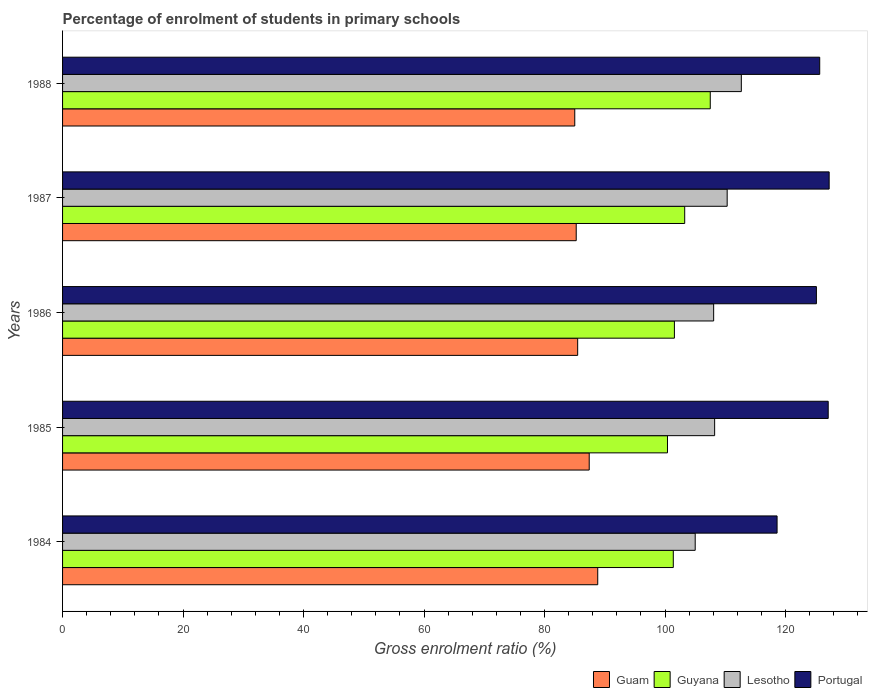How many groups of bars are there?
Provide a succinct answer. 5. Are the number of bars per tick equal to the number of legend labels?
Provide a short and direct response. Yes. What is the label of the 5th group of bars from the top?
Provide a short and direct response. 1984. In how many cases, is the number of bars for a given year not equal to the number of legend labels?
Provide a succinct answer. 0. What is the percentage of students enrolled in primary schools in Lesotho in 1985?
Ensure brevity in your answer.  108.23. Across all years, what is the maximum percentage of students enrolled in primary schools in Portugal?
Provide a succinct answer. 127.24. Across all years, what is the minimum percentage of students enrolled in primary schools in Guyana?
Provide a succinct answer. 100.4. In which year was the percentage of students enrolled in primary schools in Portugal minimum?
Your answer should be compact. 1984. What is the total percentage of students enrolled in primary schools in Guam in the graph?
Give a very brief answer. 432. What is the difference between the percentage of students enrolled in primary schools in Lesotho in 1984 and that in 1985?
Offer a very short reply. -3.23. What is the difference between the percentage of students enrolled in primary schools in Guam in 1987 and the percentage of students enrolled in primary schools in Lesotho in 1984?
Keep it short and to the point. -19.75. What is the average percentage of students enrolled in primary schools in Portugal per year?
Provide a short and direct response. 124.74. In the year 1986, what is the difference between the percentage of students enrolled in primary schools in Guam and percentage of students enrolled in primary schools in Lesotho?
Ensure brevity in your answer.  -22.57. What is the ratio of the percentage of students enrolled in primary schools in Lesotho in 1985 to that in 1987?
Your answer should be very brief. 0.98. What is the difference between the highest and the second highest percentage of students enrolled in primary schools in Guam?
Provide a succinct answer. 1.41. What is the difference between the highest and the lowest percentage of students enrolled in primary schools in Portugal?
Offer a terse response. 8.65. Is it the case that in every year, the sum of the percentage of students enrolled in primary schools in Guyana and percentage of students enrolled in primary schools in Portugal is greater than the sum of percentage of students enrolled in primary schools in Lesotho and percentage of students enrolled in primary schools in Guam?
Provide a short and direct response. No. What does the 1st bar from the top in 1985 represents?
Provide a succinct answer. Portugal. What does the 3rd bar from the bottom in 1985 represents?
Provide a short and direct response. Lesotho. Is it the case that in every year, the sum of the percentage of students enrolled in primary schools in Lesotho and percentage of students enrolled in primary schools in Portugal is greater than the percentage of students enrolled in primary schools in Guam?
Your answer should be very brief. Yes. Are all the bars in the graph horizontal?
Provide a succinct answer. Yes. Does the graph contain grids?
Give a very brief answer. No. How many legend labels are there?
Your response must be concise. 4. What is the title of the graph?
Give a very brief answer. Percentage of enrolment of students in primary schools. What is the label or title of the X-axis?
Offer a terse response. Gross enrolment ratio (%). What is the label or title of the Y-axis?
Provide a succinct answer. Years. What is the Gross enrolment ratio (%) in Guam in 1984?
Your response must be concise. 88.83. What is the Gross enrolment ratio (%) of Guyana in 1984?
Give a very brief answer. 101.37. What is the Gross enrolment ratio (%) in Lesotho in 1984?
Provide a short and direct response. 105. What is the Gross enrolment ratio (%) in Portugal in 1984?
Ensure brevity in your answer.  118.59. What is the Gross enrolment ratio (%) of Guam in 1985?
Your answer should be very brief. 87.41. What is the Gross enrolment ratio (%) of Guyana in 1985?
Give a very brief answer. 100.4. What is the Gross enrolment ratio (%) of Lesotho in 1985?
Your answer should be compact. 108.23. What is the Gross enrolment ratio (%) in Portugal in 1985?
Your answer should be compact. 127.08. What is the Gross enrolment ratio (%) of Guam in 1986?
Provide a succinct answer. 85.5. What is the Gross enrolment ratio (%) in Guyana in 1986?
Keep it short and to the point. 101.55. What is the Gross enrolment ratio (%) of Lesotho in 1986?
Offer a terse response. 108.07. What is the Gross enrolment ratio (%) in Portugal in 1986?
Make the answer very short. 125.12. What is the Gross enrolment ratio (%) in Guam in 1987?
Offer a very short reply. 85.26. What is the Gross enrolment ratio (%) of Guyana in 1987?
Offer a terse response. 103.26. What is the Gross enrolment ratio (%) of Lesotho in 1987?
Offer a very short reply. 110.31. What is the Gross enrolment ratio (%) of Portugal in 1987?
Keep it short and to the point. 127.24. What is the Gross enrolment ratio (%) in Guam in 1988?
Provide a succinct answer. 85.01. What is the Gross enrolment ratio (%) in Guyana in 1988?
Ensure brevity in your answer.  107.5. What is the Gross enrolment ratio (%) in Lesotho in 1988?
Give a very brief answer. 112.66. What is the Gross enrolment ratio (%) in Portugal in 1988?
Ensure brevity in your answer.  125.67. Across all years, what is the maximum Gross enrolment ratio (%) of Guam?
Your response must be concise. 88.83. Across all years, what is the maximum Gross enrolment ratio (%) in Guyana?
Provide a short and direct response. 107.5. Across all years, what is the maximum Gross enrolment ratio (%) of Lesotho?
Your response must be concise. 112.66. Across all years, what is the maximum Gross enrolment ratio (%) in Portugal?
Provide a succinct answer. 127.24. Across all years, what is the minimum Gross enrolment ratio (%) of Guam?
Your answer should be very brief. 85.01. Across all years, what is the minimum Gross enrolment ratio (%) of Guyana?
Your answer should be compact. 100.4. Across all years, what is the minimum Gross enrolment ratio (%) of Lesotho?
Keep it short and to the point. 105. Across all years, what is the minimum Gross enrolment ratio (%) in Portugal?
Provide a short and direct response. 118.59. What is the total Gross enrolment ratio (%) in Guam in the graph?
Offer a very short reply. 432. What is the total Gross enrolment ratio (%) in Guyana in the graph?
Your answer should be very brief. 514.08. What is the total Gross enrolment ratio (%) in Lesotho in the graph?
Your response must be concise. 544.27. What is the total Gross enrolment ratio (%) in Portugal in the graph?
Offer a very short reply. 623.7. What is the difference between the Gross enrolment ratio (%) of Guam in 1984 and that in 1985?
Provide a succinct answer. 1.41. What is the difference between the Gross enrolment ratio (%) of Guyana in 1984 and that in 1985?
Provide a short and direct response. 0.97. What is the difference between the Gross enrolment ratio (%) in Lesotho in 1984 and that in 1985?
Your response must be concise. -3.23. What is the difference between the Gross enrolment ratio (%) of Portugal in 1984 and that in 1985?
Keep it short and to the point. -8.49. What is the difference between the Gross enrolment ratio (%) in Guam in 1984 and that in 1986?
Make the answer very short. 3.33. What is the difference between the Gross enrolment ratio (%) of Guyana in 1984 and that in 1986?
Provide a short and direct response. -0.18. What is the difference between the Gross enrolment ratio (%) in Lesotho in 1984 and that in 1986?
Ensure brevity in your answer.  -3.06. What is the difference between the Gross enrolment ratio (%) of Portugal in 1984 and that in 1986?
Offer a very short reply. -6.53. What is the difference between the Gross enrolment ratio (%) of Guam in 1984 and that in 1987?
Ensure brevity in your answer.  3.57. What is the difference between the Gross enrolment ratio (%) in Guyana in 1984 and that in 1987?
Make the answer very short. -1.89. What is the difference between the Gross enrolment ratio (%) in Lesotho in 1984 and that in 1987?
Your response must be concise. -5.31. What is the difference between the Gross enrolment ratio (%) in Portugal in 1984 and that in 1987?
Offer a very short reply. -8.65. What is the difference between the Gross enrolment ratio (%) in Guam in 1984 and that in 1988?
Your answer should be very brief. 3.81. What is the difference between the Gross enrolment ratio (%) in Guyana in 1984 and that in 1988?
Provide a succinct answer. -6.13. What is the difference between the Gross enrolment ratio (%) in Lesotho in 1984 and that in 1988?
Offer a very short reply. -7.65. What is the difference between the Gross enrolment ratio (%) of Portugal in 1984 and that in 1988?
Provide a succinct answer. -7.08. What is the difference between the Gross enrolment ratio (%) in Guam in 1985 and that in 1986?
Your answer should be compact. 1.91. What is the difference between the Gross enrolment ratio (%) of Guyana in 1985 and that in 1986?
Ensure brevity in your answer.  -1.15. What is the difference between the Gross enrolment ratio (%) of Lesotho in 1985 and that in 1986?
Your answer should be compact. 0.16. What is the difference between the Gross enrolment ratio (%) in Portugal in 1985 and that in 1986?
Keep it short and to the point. 1.96. What is the difference between the Gross enrolment ratio (%) in Guam in 1985 and that in 1987?
Give a very brief answer. 2.16. What is the difference between the Gross enrolment ratio (%) in Guyana in 1985 and that in 1987?
Offer a terse response. -2.86. What is the difference between the Gross enrolment ratio (%) of Lesotho in 1985 and that in 1987?
Your response must be concise. -2.08. What is the difference between the Gross enrolment ratio (%) of Portugal in 1985 and that in 1987?
Give a very brief answer. -0.16. What is the difference between the Gross enrolment ratio (%) of Guam in 1985 and that in 1988?
Offer a very short reply. 2.4. What is the difference between the Gross enrolment ratio (%) in Guyana in 1985 and that in 1988?
Provide a short and direct response. -7.1. What is the difference between the Gross enrolment ratio (%) in Lesotho in 1985 and that in 1988?
Offer a very short reply. -4.43. What is the difference between the Gross enrolment ratio (%) in Portugal in 1985 and that in 1988?
Offer a terse response. 1.41. What is the difference between the Gross enrolment ratio (%) of Guam in 1986 and that in 1987?
Give a very brief answer. 0.24. What is the difference between the Gross enrolment ratio (%) of Guyana in 1986 and that in 1987?
Make the answer very short. -1.71. What is the difference between the Gross enrolment ratio (%) of Lesotho in 1986 and that in 1987?
Offer a terse response. -2.24. What is the difference between the Gross enrolment ratio (%) in Portugal in 1986 and that in 1987?
Offer a terse response. -2.12. What is the difference between the Gross enrolment ratio (%) of Guam in 1986 and that in 1988?
Provide a succinct answer. 0.48. What is the difference between the Gross enrolment ratio (%) of Guyana in 1986 and that in 1988?
Give a very brief answer. -5.95. What is the difference between the Gross enrolment ratio (%) of Lesotho in 1986 and that in 1988?
Your answer should be compact. -4.59. What is the difference between the Gross enrolment ratio (%) of Portugal in 1986 and that in 1988?
Give a very brief answer. -0.55. What is the difference between the Gross enrolment ratio (%) in Guam in 1987 and that in 1988?
Give a very brief answer. 0.24. What is the difference between the Gross enrolment ratio (%) in Guyana in 1987 and that in 1988?
Ensure brevity in your answer.  -4.24. What is the difference between the Gross enrolment ratio (%) in Lesotho in 1987 and that in 1988?
Provide a short and direct response. -2.35. What is the difference between the Gross enrolment ratio (%) in Portugal in 1987 and that in 1988?
Provide a short and direct response. 1.57. What is the difference between the Gross enrolment ratio (%) in Guam in 1984 and the Gross enrolment ratio (%) in Guyana in 1985?
Make the answer very short. -11.58. What is the difference between the Gross enrolment ratio (%) in Guam in 1984 and the Gross enrolment ratio (%) in Lesotho in 1985?
Give a very brief answer. -19.4. What is the difference between the Gross enrolment ratio (%) of Guam in 1984 and the Gross enrolment ratio (%) of Portugal in 1985?
Provide a succinct answer. -38.25. What is the difference between the Gross enrolment ratio (%) in Guyana in 1984 and the Gross enrolment ratio (%) in Lesotho in 1985?
Your answer should be compact. -6.86. What is the difference between the Gross enrolment ratio (%) of Guyana in 1984 and the Gross enrolment ratio (%) of Portugal in 1985?
Offer a terse response. -25.71. What is the difference between the Gross enrolment ratio (%) in Lesotho in 1984 and the Gross enrolment ratio (%) in Portugal in 1985?
Provide a short and direct response. -22.08. What is the difference between the Gross enrolment ratio (%) in Guam in 1984 and the Gross enrolment ratio (%) in Guyana in 1986?
Ensure brevity in your answer.  -12.73. What is the difference between the Gross enrolment ratio (%) in Guam in 1984 and the Gross enrolment ratio (%) in Lesotho in 1986?
Offer a terse response. -19.24. What is the difference between the Gross enrolment ratio (%) in Guam in 1984 and the Gross enrolment ratio (%) in Portugal in 1986?
Give a very brief answer. -36.29. What is the difference between the Gross enrolment ratio (%) in Guyana in 1984 and the Gross enrolment ratio (%) in Lesotho in 1986?
Provide a succinct answer. -6.7. What is the difference between the Gross enrolment ratio (%) of Guyana in 1984 and the Gross enrolment ratio (%) of Portugal in 1986?
Provide a short and direct response. -23.75. What is the difference between the Gross enrolment ratio (%) of Lesotho in 1984 and the Gross enrolment ratio (%) of Portugal in 1986?
Give a very brief answer. -20.12. What is the difference between the Gross enrolment ratio (%) of Guam in 1984 and the Gross enrolment ratio (%) of Guyana in 1987?
Provide a succinct answer. -14.43. What is the difference between the Gross enrolment ratio (%) of Guam in 1984 and the Gross enrolment ratio (%) of Lesotho in 1987?
Ensure brevity in your answer.  -21.48. What is the difference between the Gross enrolment ratio (%) of Guam in 1984 and the Gross enrolment ratio (%) of Portugal in 1987?
Provide a succinct answer. -38.41. What is the difference between the Gross enrolment ratio (%) in Guyana in 1984 and the Gross enrolment ratio (%) in Lesotho in 1987?
Provide a succinct answer. -8.94. What is the difference between the Gross enrolment ratio (%) in Guyana in 1984 and the Gross enrolment ratio (%) in Portugal in 1987?
Your response must be concise. -25.87. What is the difference between the Gross enrolment ratio (%) in Lesotho in 1984 and the Gross enrolment ratio (%) in Portugal in 1987?
Give a very brief answer. -22.23. What is the difference between the Gross enrolment ratio (%) in Guam in 1984 and the Gross enrolment ratio (%) in Guyana in 1988?
Provide a succinct answer. -18.68. What is the difference between the Gross enrolment ratio (%) of Guam in 1984 and the Gross enrolment ratio (%) of Lesotho in 1988?
Your answer should be very brief. -23.83. What is the difference between the Gross enrolment ratio (%) of Guam in 1984 and the Gross enrolment ratio (%) of Portugal in 1988?
Your answer should be compact. -36.84. What is the difference between the Gross enrolment ratio (%) of Guyana in 1984 and the Gross enrolment ratio (%) of Lesotho in 1988?
Ensure brevity in your answer.  -11.29. What is the difference between the Gross enrolment ratio (%) in Guyana in 1984 and the Gross enrolment ratio (%) in Portugal in 1988?
Give a very brief answer. -24.3. What is the difference between the Gross enrolment ratio (%) in Lesotho in 1984 and the Gross enrolment ratio (%) in Portugal in 1988?
Your answer should be compact. -20.67. What is the difference between the Gross enrolment ratio (%) in Guam in 1985 and the Gross enrolment ratio (%) in Guyana in 1986?
Offer a very short reply. -14.14. What is the difference between the Gross enrolment ratio (%) in Guam in 1985 and the Gross enrolment ratio (%) in Lesotho in 1986?
Give a very brief answer. -20.65. What is the difference between the Gross enrolment ratio (%) in Guam in 1985 and the Gross enrolment ratio (%) in Portugal in 1986?
Your answer should be compact. -37.71. What is the difference between the Gross enrolment ratio (%) in Guyana in 1985 and the Gross enrolment ratio (%) in Lesotho in 1986?
Give a very brief answer. -7.66. What is the difference between the Gross enrolment ratio (%) of Guyana in 1985 and the Gross enrolment ratio (%) of Portugal in 1986?
Make the answer very short. -24.72. What is the difference between the Gross enrolment ratio (%) of Lesotho in 1985 and the Gross enrolment ratio (%) of Portugal in 1986?
Offer a very short reply. -16.89. What is the difference between the Gross enrolment ratio (%) in Guam in 1985 and the Gross enrolment ratio (%) in Guyana in 1987?
Ensure brevity in your answer.  -15.85. What is the difference between the Gross enrolment ratio (%) of Guam in 1985 and the Gross enrolment ratio (%) of Lesotho in 1987?
Offer a terse response. -22.9. What is the difference between the Gross enrolment ratio (%) in Guam in 1985 and the Gross enrolment ratio (%) in Portugal in 1987?
Make the answer very short. -39.83. What is the difference between the Gross enrolment ratio (%) in Guyana in 1985 and the Gross enrolment ratio (%) in Lesotho in 1987?
Your answer should be compact. -9.91. What is the difference between the Gross enrolment ratio (%) of Guyana in 1985 and the Gross enrolment ratio (%) of Portugal in 1987?
Keep it short and to the point. -26.84. What is the difference between the Gross enrolment ratio (%) of Lesotho in 1985 and the Gross enrolment ratio (%) of Portugal in 1987?
Your answer should be very brief. -19.01. What is the difference between the Gross enrolment ratio (%) of Guam in 1985 and the Gross enrolment ratio (%) of Guyana in 1988?
Offer a very short reply. -20.09. What is the difference between the Gross enrolment ratio (%) of Guam in 1985 and the Gross enrolment ratio (%) of Lesotho in 1988?
Give a very brief answer. -25.25. What is the difference between the Gross enrolment ratio (%) of Guam in 1985 and the Gross enrolment ratio (%) of Portugal in 1988?
Your response must be concise. -38.26. What is the difference between the Gross enrolment ratio (%) of Guyana in 1985 and the Gross enrolment ratio (%) of Lesotho in 1988?
Give a very brief answer. -12.26. What is the difference between the Gross enrolment ratio (%) of Guyana in 1985 and the Gross enrolment ratio (%) of Portugal in 1988?
Give a very brief answer. -25.27. What is the difference between the Gross enrolment ratio (%) of Lesotho in 1985 and the Gross enrolment ratio (%) of Portugal in 1988?
Provide a short and direct response. -17.44. What is the difference between the Gross enrolment ratio (%) in Guam in 1986 and the Gross enrolment ratio (%) in Guyana in 1987?
Offer a very short reply. -17.76. What is the difference between the Gross enrolment ratio (%) of Guam in 1986 and the Gross enrolment ratio (%) of Lesotho in 1987?
Your answer should be compact. -24.81. What is the difference between the Gross enrolment ratio (%) in Guam in 1986 and the Gross enrolment ratio (%) in Portugal in 1987?
Give a very brief answer. -41.74. What is the difference between the Gross enrolment ratio (%) of Guyana in 1986 and the Gross enrolment ratio (%) of Lesotho in 1987?
Offer a terse response. -8.76. What is the difference between the Gross enrolment ratio (%) in Guyana in 1986 and the Gross enrolment ratio (%) in Portugal in 1987?
Make the answer very short. -25.69. What is the difference between the Gross enrolment ratio (%) in Lesotho in 1986 and the Gross enrolment ratio (%) in Portugal in 1987?
Keep it short and to the point. -19.17. What is the difference between the Gross enrolment ratio (%) of Guam in 1986 and the Gross enrolment ratio (%) of Guyana in 1988?
Offer a terse response. -22.01. What is the difference between the Gross enrolment ratio (%) of Guam in 1986 and the Gross enrolment ratio (%) of Lesotho in 1988?
Ensure brevity in your answer.  -27.16. What is the difference between the Gross enrolment ratio (%) of Guam in 1986 and the Gross enrolment ratio (%) of Portugal in 1988?
Provide a succinct answer. -40.17. What is the difference between the Gross enrolment ratio (%) in Guyana in 1986 and the Gross enrolment ratio (%) in Lesotho in 1988?
Make the answer very short. -11.11. What is the difference between the Gross enrolment ratio (%) in Guyana in 1986 and the Gross enrolment ratio (%) in Portugal in 1988?
Offer a terse response. -24.12. What is the difference between the Gross enrolment ratio (%) in Lesotho in 1986 and the Gross enrolment ratio (%) in Portugal in 1988?
Keep it short and to the point. -17.6. What is the difference between the Gross enrolment ratio (%) of Guam in 1987 and the Gross enrolment ratio (%) of Guyana in 1988?
Offer a very short reply. -22.25. What is the difference between the Gross enrolment ratio (%) of Guam in 1987 and the Gross enrolment ratio (%) of Lesotho in 1988?
Your response must be concise. -27.4. What is the difference between the Gross enrolment ratio (%) of Guam in 1987 and the Gross enrolment ratio (%) of Portugal in 1988?
Keep it short and to the point. -40.41. What is the difference between the Gross enrolment ratio (%) in Guyana in 1987 and the Gross enrolment ratio (%) in Lesotho in 1988?
Ensure brevity in your answer.  -9.4. What is the difference between the Gross enrolment ratio (%) of Guyana in 1987 and the Gross enrolment ratio (%) of Portugal in 1988?
Provide a short and direct response. -22.41. What is the difference between the Gross enrolment ratio (%) in Lesotho in 1987 and the Gross enrolment ratio (%) in Portugal in 1988?
Ensure brevity in your answer.  -15.36. What is the average Gross enrolment ratio (%) in Guam per year?
Give a very brief answer. 86.4. What is the average Gross enrolment ratio (%) of Guyana per year?
Your answer should be very brief. 102.82. What is the average Gross enrolment ratio (%) in Lesotho per year?
Offer a very short reply. 108.85. What is the average Gross enrolment ratio (%) of Portugal per year?
Give a very brief answer. 124.74. In the year 1984, what is the difference between the Gross enrolment ratio (%) of Guam and Gross enrolment ratio (%) of Guyana?
Make the answer very short. -12.54. In the year 1984, what is the difference between the Gross enrolment ratio (%) of Guam and Gross enrolment ratio (%) of Lesotho?
Offer a terse response. -16.18. In the year 1984, what is the difference between the Gross enrolment ratio (%) of Guam and Gross enrolment ratio (%) of Portugal?
Keep it short and to the point. -29.77. In the year 1984, what is the difference between the Gross enrolment ratio (%) of Guyana and Gross enrolment ratio (%) of Lesotho?
Provide a succinct answer. -3.64. In the year 1984, what is the difference between the Gross enrolment ratio (%) of Guyana and Gross enrolment ratio (%) of Portugal?
Provide a succinct answer. -17.22. In the year 1984, what is the difference between the Gross enrolment ratio (%) of Lesotho and Gross enrolment ratio (%) of Portugal?
Make the answer very short. -13.59. In the year 1985, what is the difference between the Gross enrolment ratio (%) in Guam and Gross enrolment ratio (%) in Guyana?
Offer a very short reply. -12.99. In the year 1985, what is the difference between the Gross enrolment ratio (%) in Guam and Gross enrolment ratio (%) in Lesotho?
Provide a succinct answer. -20.82. In the year 1985, what is the difference between the Gross enrolment ratio (%) of Guam and Gross enrolment ratio (%) of Portugal?
Ensure brevity in your answer.  -39.67. In the year 1985, what is the difference between the Gross enrolment ratio (%) of Guyana and Gross enrolment ratio (%) of Lesotho?
Your response must be concise. -7.83. In the year 1985, what is the difference between the Gross enrolment ratio (%) in Guyana and Gross enrolment ratio (%) in Portugal?
Offer a terse response. -26.68. In the year 1985, what is the difference between the Gross enrolment ratio (%) of Lesotho and Gross enrolment ratio (%) of Portugal?
Offer a very short reply. -18.85. In the year 1986, what is the difference between the Gross enrolment ratio (%) in Guam and Gross enrolment ratio (%) in Guyana?
Provide a short and direct response. -16.05. In the year 1986, what is the difference between the Gross enrolment ratio (%) of Guam and Gross enrolment ratio (%) of Lesotho?
Give a very brief answer. -22.57. In the year 1986, what is the difference between the Gross enrolment ratio (%) in Guam and Gross enrolment ratio (%) in Portugal?
Your answer should be very brief. -39.62. In the year 1986, what is the difference between the Gross enrolment ratio (%) in Guyana and Gross enrolment ratio (%) in Lesotho?
Your answer should be compact. -6.51. In the year 1986, what is the difference between the Gross enrolment ratio (%) of Guyana and Gross enrolment ratio (%) of Portugal?
Provide a succinct answer. -23.57. In the year 1986, what is the difference between the Gross enrolment ratio (%) in Lesotho and Gross enrolment ratio (%) in Portugal?
Provide a succinct answer. -17.05. In the year 1987, what is the difference between the Gross enrolment ratio (%) of Guam and Gross enrolment ratio (%) of Guyana?
Make the answer very short. -18.01. In the year 1987, what is the difference between the Gross enrolment ratio (%) in Guam and Gross enrolment ratio (%) in Lesotho?
Your answer should be compact. -25.05. In the year 1987, what is the difference between the Gross enrolment ratio (%) of Guam and Gross enrolment ratio (%) of Portugal?
Offer a terse response. -41.98. In the year 1987, what is the difference between the Gross enrolment ratio (%) in Guyana and Gross enrolment ratio (%) in Lesotho?
Your answer should be compact. -7.05. In the year 1987, what is the difference between the Gross enrolment ratio (%) in Guyana and Gross enrolment ratio (%) in Portugal?
Provide a short and direct response. -23.98. In the year 1987, what is the difference between the Gross enrolment ratio (%) in Lesotho and Gross enrolment ratio (%) in Portugal?
Provide a short and direct response. -16.93. In the year 1988, what is the difference between the Gross enrolment ratio (%) of Guam and Gross enrolment ratio (%) of Guyana?
Your answer should be very brief. -22.49. In the year 1988, what is the difference between the Gross enrolment ratio (%) in Guam and Gross enrolment ratio (%) in Lesotho?
Provide a succinct answer. -27.65. In the year 1988, what is the difference between the Gross enrolment ratio (%) of Guam and Gross enrolment ratio (%) of Portugal?
Provide a short and direct response. -40.66. In the year 1988, what is the difference between the Gross enrolment ratio (%) in Guyana and Gross enrolment ratio (%) in Lesotho?
Provide a succinct answer. -5.16. In the year 1988, what is the difference between the Gross enrolment ratio (%) in Guyana and Gross enrolment ratio (%) in Portugal?
Ensure brevity in your answer.  -18.17. In the year 1988, what is the difference between the Gross enrolment ratio (%) in Lesotho and Gross enrolment ratio (%) in Portugal?
Give a very brief answer. -13.01. What is the ratio of the Gross enrolment ratio (%) in Guam in 1984 to that in 1985?
Provide a short and direct response. 1.02. What is the ratio of the Gross enrolment ratio (%) in Guyana in 1984 to that in 1985?
Give a very brief answer. 1.01. What is the ratio of the Gross enrolment ratio (%) of Lesotho in 1984 to that in 1985?
Give a very brief answer. 0.97. What is the ratio of the Gross enrolment ratio (%) of Portugal in 1984 to that in 1985?
Give a very brief answer. 0.93. What is the ratio of the Gross enrolment ratio (%) in Guam in 1984 to that in 1986?
Provide a short and direct response. 1.04. What is the ratio of the Gross enrolment ratio (%) of Guyana in 1984 to that in 1986?
Your answer should be very brief. 1. What is the ratio of the Gross enrolment ratio (%) of Lesotho in 1984 to that in 1986?
Make the answer very short. 0.97. What is the ratio of the Gross enrolment ratio (%) of Portugal in 1984 to that in 1986?
Keep it short and to the point. 0.95. What is the ratio of the Gross enrolment ratio (%) in Guam in 1984 to that in 1987?
Give a very brief answer. 1.04. What is the ratio of the Gross enrolment ratio (%) in Guyana in 1984 to that in 1987?
Your answer should be very brief. 0.98. What is the ratio of the Gross enrolment ratio (%) of Lesotho in 1984 to that in 1987?
Your answer should be compact. 0.95. What is the ratio of the Gross enrolment ratio (%) in Portugal in 1984 to that in 1987?
Your answer should be compact. 0.93. What is the ratio of the Gross enrolment ratio (%) in Guam in 1984 to that in 1988?
Keep it short and to the point. 1.04. What is the ratio of the Gross enrolment ratio (%) in Guyana in 1984 to that in 1988?
Your answer should be very brief. 0.94. What is the ratio of the Gross enrolment ratio (%) in Lesotho in 1984 to that in 1988?
Provide a succinct answer. 0.93. What is the ratio of the Gross enrolment ratio (%) in Portugal in 1984 to that in 1988?
Your answer should be compact. 0.94. What is the ratio of the Gross enrolment ratio (%) of Guam in 1985 to that in 1986?
Offer a terse response. 1.02. What is the ratio of the Gross enrolment ratio (%) in Guyana in 1985 to that in 1986?
Provide a succinct answer. 0.99. What is the ratio of the Gross enrolment ratio (%) of Lesotho in 1985 to that in 1986?
Your answer should be very brief. 1. What is the ratio of the Gross enrolment ratio (%) in Portugal in 1985 to that in 1986?
Keep it short and to the point. 1.02. What is the ratio of the Gross enrolment ratio (%) in Guam in 1985 to that in 1987?
Make the answer very short. 1.03. What is the ratio of the Gross enrolment ratio (%) of Guyana in 1985 to that in 1987?
Your answer should be compact. 0.97. What is the ratio of the Gross enrolment ratio (%) in Lesotho in 1985 to that in 1987?
Your answer should be compact. 0.98. What is the ratio of the Gross enrolment ratio (%) in Portugal in 1985 to that in 1987?
Provide a short and direct response. 1. What is the ratio of the Gross enrolment ratio (%) in Guam in 1985 to that in 1988?
Keep it short and to the point. 1.03. What is the ratio of the Gross enrolment ratio (%) in Guyana in 1985 to that in 1988?
Ensure brevity in your answer.  0.93. What is the ratio of the Gross enrolment ratio (%) in Lesotho in 1985 to that in 1988?
Your answer should be compact. 0.96. What is the ratio of the Gross enrolment ratio (%) of Portugal in 1985 to that in 1988?
Provide a succinct answer. 1.01. What is the ratio of the Gross enrolment ratio (%) in Guam in 1986 to that in 1987?
Provide a succinct answer. 1. What is the ratio of the Gross enrolment ratio (%) in Guyana in 1986 to that in 1987?
Your answer should be compact. 0.98. What is the ratio of the Gross enrolment ratio (%) of Lesotho in 1986 to that in 1987?
Offer a very short reply. 0.98. What is the ratio of the Gross enrolment ratio (%) in Portugal in 1986 to that in 1987?
Your response must be concise. 0.98. What is the ratio of the Gross enrolment ratio (%) in Guyana in 1986 to that in 1988?
Keep it short and to the point. 0.94. What is the ratio of the Gross enrolment ratio (%) of Lesotho in 1986 to that in 1988?
Give a very brief answer. 0.96. What is the ratio of the Gross enrolment ratio (%) of Guyana in 1987 to that in 1988?
Give a very brief answer. 0.96. What is the ratio of the Gross enrolment ratio (%) of Lesotho in 1987 to that in 1988?
Your answer should be compact. 0.98. What is the ratio of the Gross enrolment ratio (%) of Portugal in 1987 to that in 1988?
Offer a terse response. 1.01. What is the difference between the highest and the second highest Gross enrolment ratio (%) in Guam?
Keep it short and to the point. 1.41. What is the difference between the highest and the second highest Gross enrolment ratio (%) of Guyana?
Provide a succinct answer. 4.24. What is the difference between the highest and the second highest Gross enrolment ratio (%) of Lesotho?
Provide a succinct answer. 2.35. What is the difference between the highest and the second highest Gross enrolment ratio (%) of Portugal?
Provide a short and direct response. 0.16. What is the difference between the highest and the lowest Gross enrolment ratio (%) in Guam?
Provide a succinct answer. 3.81. What is the difference between the highest and the lowest Gross enrolment ratio (%) of Guyana?
Your response must be concise. 7.1. What is the difference between the highest and the lowest Gross enrolment ratio (%) in Lesotho?
Ensure brevity in your answer.  7.65. What is the difference between the highest and the lowest Gross enrolment ratio (%) in Portugal?
Provide a short and direct response. 8.65. 